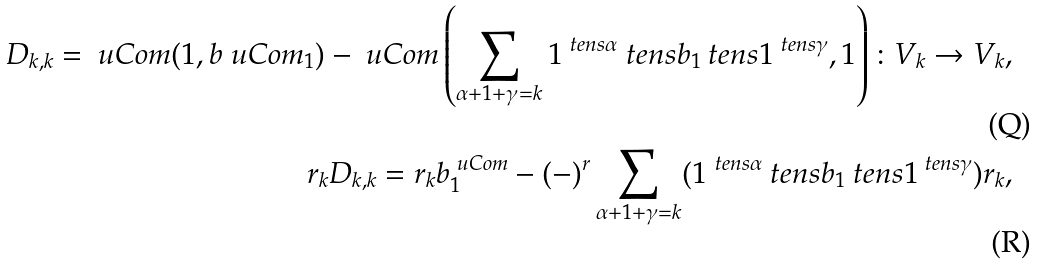<formula> <loc_0><loc_0><loc_500><loc_500>D _ { k , k } = \ u C o m ( 1 , b ^ { \ } u C o m _ { 1 } ) - \ u C o m \left ( \sum _ { \alpha + 1 + \gamma = k } 1 ^ { \ t e n s \alpha } \ t e n s b _ { 1 } \ t e n s 1 ^ { \ t e n s \gamma } , 1 \right ) \colon V _ { k } \to V _ { k } , \\ r _ { k } D _ { k , k } = r _ { k } b _ { 1 } ^ { \ u C o m } - ( - ) ^ { r } \sum _ { \alpha + 1 + \gamma = k } ( 1 ^ { \ t e n s \alpha } \ t e n s b _ { 1 } \ t e n s 1 ^ { \ t e n s \gamma } ) r _ { k } ,</formula> 